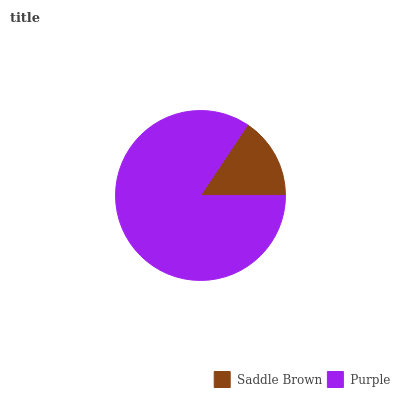Is Saddle Brown the minimum?
Answer yes or no. Yes. Is Purple the maximum?
Answer yes or no. Yes. Is Purple the minimum?
Answer yes or no. No. Is Purple greater than Saddle Brown?
Answer yes or no. Yes. Is Saddle Brown less than Purple?
Answer yes or no. Yes. Is Saddle Brown greater than Purple?
Answer yes or no. No. Is Purple less than Saddle Brown?
Answer yes or no. No. Is Purple the high median?
Answer yes or no. Yes. Is Saddle Brown the low median?
Answer yes or no. Yes. Is Saddle Brown the high median?
Answer yes or no. No. Is Purple the low median?
Answer yes or no. No. 